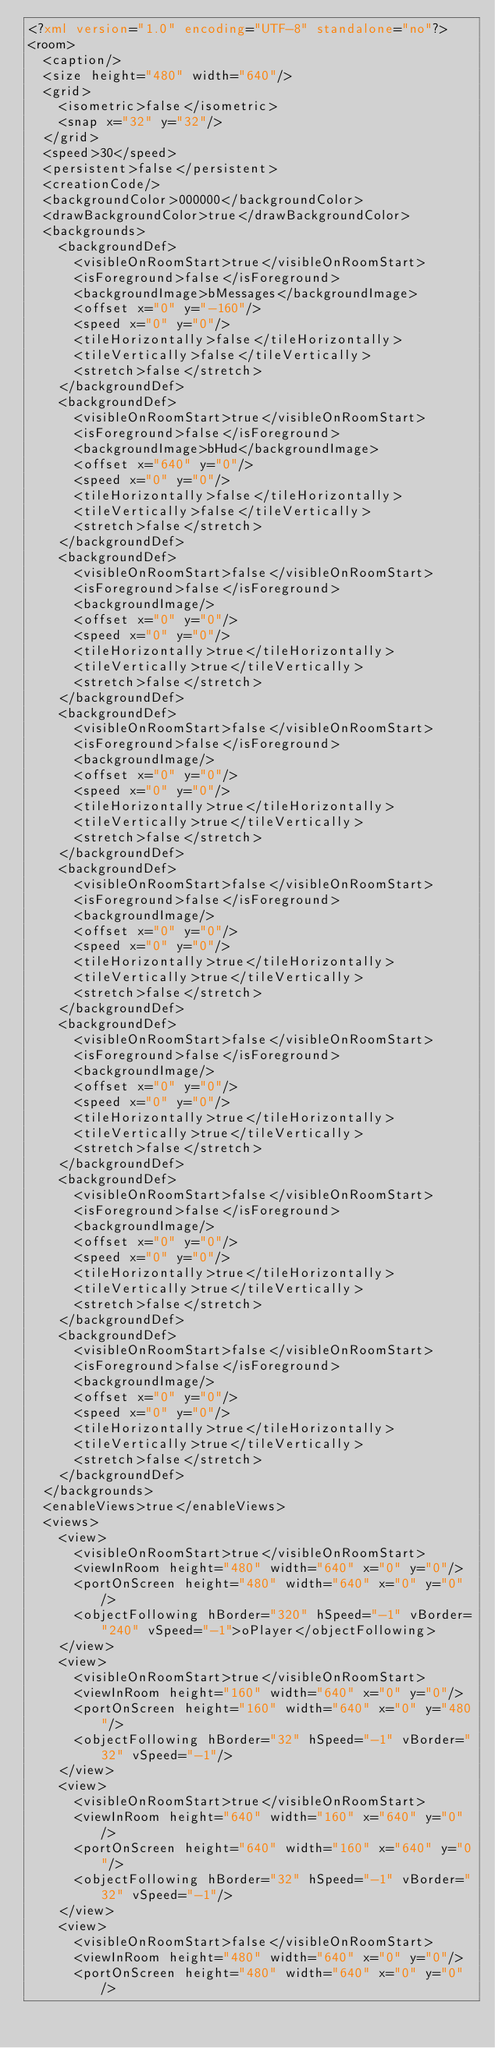Convert code to text. <code><loc_0><loc_0><loc_500><loc_500><_XML_><?xml version="1.0" encoding="UTF-8" standalone="no"?>
<room>
  <caption/>
  <size height="480" width="640"/>
  <grid>
    <isometric>false</isometric>
    <snap x="32" y="32"/>
  </grid>
  <speed>30</speed>
  <persistent>false</persistent>
  <creationCode/>
  <backgroundColor>000000</backgroundColor>
  <drawBackgroundColor>true</drawBackgroundColor>
  <backgrounds>
    <backgroundDef>
      <visibleOnRoomStart>true</visibleOnRoomStart>
      <isForeground>false</isForeground>
      <backgroundImage>bMessages</backgroundImage>
      <offset x="0" y="-160"/>
      <speed x="0" y="0"/>
      <tileHorizontally>false</tileHorizontally>
      <tileVertically>false</tileVertically>
      <stretch>false</stretch>
    </backgroundDef>
    <backgroundDef>
      <visibleOnRoomStart>true</visibleOnRoomStart>
      <isForeground>false</isForeground>
      <backgroundImage>bHud</backgroundImage>
      <offset x="640" y="0"/>
      <speed x="0" y="0"/>
      <tileHorizontally>false</tileHorizontally>
      <tileVertically>false</tileVertically>
      <stretch>false</stretch>
    </backgroundDef>
    <backgroundDef>
      <visibleOnRoomStart>false</visibleOnRoomStart>
      <isForeground>false</isForeground>
      <backgroundImage/>
      <offset x="0" y="0"/>
      <speed x="0" y="0"/>
      <tileHorizontally>true</tileHorizontally>
      <tileVertically>true</tileVertically>
      <stretch>false</stretch>
    </backgroundDef>
    <backgroundDef>
      <visibleOnRoomStart>false</visibleOnRoomStart>
      <isForeground>false</isForeground>
      <backgroundImage/>
      <offset x="0" y="0"/>
      <speed x="0" y="0"/>
      <tileHorizontally>true</tileHorizontally>
      <tileVertically>true</tileVertically>
      <stretch>false</stretch>
    </backgroundDef>
    <backgroundDef>
      <visibleOnRoomStart>false</visibleOnRoomStart>
      <isForeground>false</isForeground>
      <backgroundImage/>
      <offset x="0" y="0"/>
      <speed x="0" y="0"/>
      <tileHorizontally>true</tileHorizontally>
      <tileVertically>true</tileVertically>
      <stretch>false</stretch>
    </backgroundDef>
    <backgroundDef>
      <visibleOnRoomStart>false</visibleOnRoomStart>
      <isForeground>false</isForeground>
      <backgroundImage/>
      <offset x="0" y="0"/>
      <speed x="0" y="0"/>
      <tileHorizontally>true</tileHorizontally>
      <tileVertically>true</tileVertically>
      <stretch>false</stretch>
    </backgroundDef>
    <backgroundDef>
      <visibleOnRoomStart>false</visibleOnRoomStart>
      <isForeground>false</isForeground>
      <backgroundImage/>
      <offset x="0" y="0"/>
      <speed x="0" y="0"/>
      <tileHorizontally>true</tileHorizontally>
      <tileVertically>true</tileVertically>
      <stretch>false</stretch>
    </backgroundDef>
    <backgroundDef>
      <visibleOnRoomStart>false</visibleOnRoomStart>
      <isForeground>false</isForeground>
      <backgroundImage/>
      <offset x="0" y="0"/>
      <speed x="0" y="0"/>
      <tileHorizontally>true</tileHorizontally>
      <tileVertically>true</tileVertically>
      <stretch>false</stretch>
    </backgroundDef>
  </backgrounds>
  <enableViews>true</enableViews>
  <views>
    <view>
      <visibleOnRoomStart>true</visibleOnRoomStart>
      <viewInRoom height="480" width="640" x="0" y="0"/>
      <portOnScreen height="480" width="640" x="0" y="0"/>
      <objectFollowing hBorder="320" hSpeed="-1" vBorder="240" vSpeed="-1">oPlayer</objectFollowing>
    </view>
    <view>
      <visibleOnRoomStart>true</visibleOnRoomStart>
      <viewInRoom height="160" width="640" x="0" y="0"/>
      <portOnScreen height="160" width="640" x="0" y="480"/>
      <objectFollowing hBorder="32" hSpeed="-1" vBorder="32" vSpeed="-1"/>
    </view>
    <view>
      <visibleOnRoomStart>true</visibleOnRoomStart>
      <viewInRoom height="640" width="160" x="640" y="0"/>
      <portOnScreen height="640" width="160" x="640" y="0"/>
      <objectFollowing hBorder="32" hSpeed="-1" vBorder="32" vSpeed="-1"/>
    </view>
    <view>
      <visibleOnRoomStart>false</visibleOnRoomStart>
      <viewInRoom height="480" width="640" x="0" y="0"/>
      <portOnScreen height="480" width="640" x="0" y="0"/></code> 